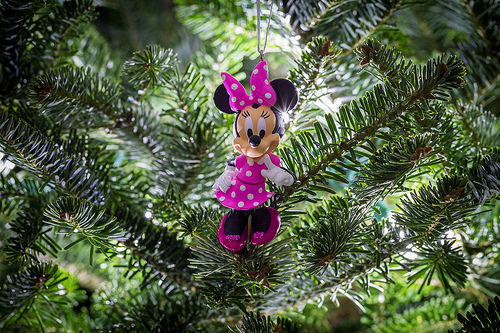<image>
Is there a ornament on the branch? Yes. Looking at the image, I can see the ornament is positioned on top of the branch, with the branch providing support. Is the doll under the tree? Yes. The doll is positioned underneath the tree, with the tree above it in the vertical space. 